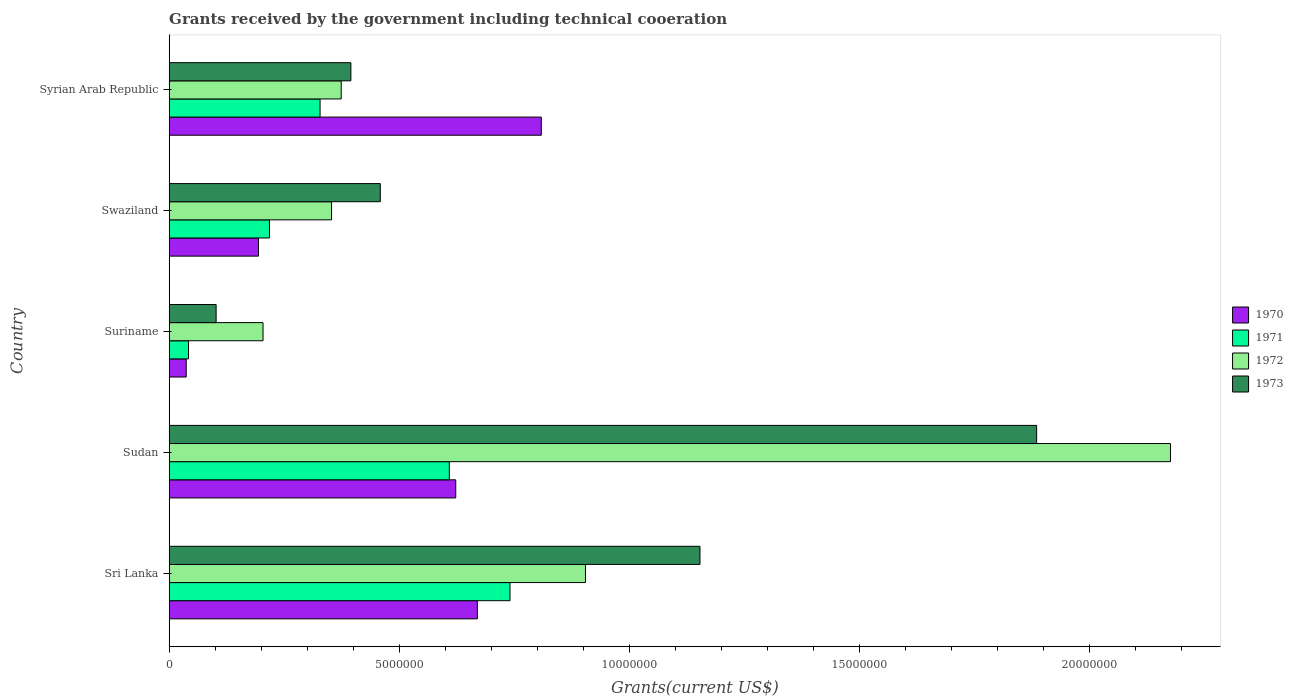Are the number of bars per tick equal to the number of legend labels?
Give a very brief answer. Yes. Are the number of bars on each tick of the Y-axis equal?
Offer a terse response. Yes. How many bars are there on the 5th tick from the bottom?
Give a very brief answer. 4. What is the label of the 3rd group of bars from the top?
Provide a short and direct response. Suriname. What is the total grants received by the government in 1973 in Sri Lanka?
Keep it short and to the point. 1.15e+07. Across all countries, what is the maximum total grants received by the government in 1973?
Your answer should be very brief. 1.89e+07. Across all countries, what is the minimum total grants received by the government in 1972?
Make the answer very short. 2.04e+06. In which country was the total grants received by the government in 1972 maximum?
Offer a very short reply. Sudan. In which country was the total grants received by the government in 1970 minimum?
Ensure brevity in your answer.  Suriname. What is the total total grants received by the government in 1971 in the graph?
Provide a short and direct response. 1.94e+07. What is the difference between the total grants received by the government in 1971 in Suriname and that in Swaziland?
Give a very brief answer. -1.76e+06. What is the difference between the total grants received by the government in 1970 in Suriname and the total grants received by the government in 1971 in Sri Lanka?
Make the answer very short. -7.04e+06. What is the average total grants received by the government in 1972 per country?
Keep it short and to the point. 8.03e+06. What is the difference between the total grants received by the government in 1971 and total grants received by the government in 1973 in Swaziland?
Give a very brief answer. -2.41e+06. In how many countries, is the total grants received by the government in 1970 greater than 17000000 US$?
Give a very brief answer. 0. What is the ratio of the total grants received by the government in 1972 in Sri Lanka to that in Suriname?
Offer a very short reply. 4.44. Is the difference between the total grants received by the government in 1971 in Sri Lanka and Sudan greater than the difference between the total grants received by the government in 1973 in Sri Lanka and Sudan?
Your answer should be very brief. Yes. What is the difference between the highest and the second highest total grants received by the government in 1970?
Keep it short and to the point. 1.39e+06. What is the difference between the highest and the lowest total grants received by the government in 1973?
Provide a succinct answer. 1.78e+07. Is the sum of the total grants received by the government in 1970 in Sudan and Suriname greater than the maximum total grants received by the government in 1973 across all countries?
Give a very brief answer. No. Is it the case that in every country, the sum of the total grants received by the government in 1972 and total grants received by the government in 1973 is greater than the sum of total grants received by the government in 1971 and total grants received by the government in 1970?
Provide a short and direct response. No. What does the 2nd bar from the top in Syrian Arab Republic represents?
Give a very brief answer. 1972. Is it the case that in every country, the sum of the total grants received by the government in 1970 and total grants received by the government in 1971 is greater than the total grants received by the government in 1973?
Your answer should be very brief. No. What is the difference between two consecutive major ticks on the X-axis?
Provide a succinct answer. 5.00e+06. Are the values on the major ticks of X-axis written in scientific E-notation?
Offer a terse response. No. How are the legend labels stacked?
Your answer should be compact. Vertical. What is the title of the graph?
Keep it short and to the point. Grants received by the government including technical cooeration. What is the label or title of the X-axis?
Your answer should be very brief. Grants(current US$). What is the Grants(current US$) in 1970 in Sri Lanka?
Make the answer very short. 6.70e+06. What is the Grants(current US$) of 1971 in Sri Lanka?
Your answer should be very brief. 7.41e+06. What is the Grants(current US$) of 1972 in Sri Lanka?
Offer a very short reply. 9.05e+06. What is the Grants(current US$) in 1973 in Sri Lanka?
Ensure brevity in your answer.  1.15e+07. What is the Grants(current US$) of 1970 in Sudan?
Provide a short and direct response. 6.23e+06. What is the Grants(current US$) in 1971 in Sudan?
Keep it short and to the point. 6.09e+06. What is the Grants(current US$) in 1972 in Sudan?
Make the answer very short. 2.18e+07. What is the Grants(current US$) in 1973 in Sudan?
Provide a short and direct response. 1.89e+07. What is the Grants(current US$) in 1972 in Suriname?
Offer a terse response. 2.04e+06. What is the Grants(current US$) in 1973 in Suriname?
Provide a short and direct response. 1.02e+06. What is the Grants(current US$) of 1970 in Swaziland?
Ensure brevity in your answer.  1.94e+06. What is the Grants(current US$) of 1971 in Swaziland?
Provide a short and direct response. 2.18e+06. What is the Grants(current US$) of 1972 in Swaziland?
Your answer should be compact. 3.53e+06. What is the Grants(current US$) in 1973 in Swaziland?
Keep it short and to the point. 4.59e+06. What is the Grants(current US$) of 1970 in Syrian Arab Republic?
Provide a succinct answer. 8.09e+06. What is the Grants(current US$) in 1971 in Syrian Arab Republic?
Keep it short and to the point. 3.28e+06. What is the Grants(current US$) in 1972 in Syrian Arab Republic?
Make the answer very short. 3.74e+06. What is the Grants(current US$) of 1973 in Syrian Arab Republic?
Give a very brief answer. 3.95e+06. Across all countries, what is the maximum Grants(current US$) of 1970?
Give a very brief answer. 8.09e+06. Across all countries, what is the maximum Grants(current US$) of 1971?
Your answer should be compact. 7.41e+06. Across all countries, what is the maximum Grants(current US$) in 1972?
Give a very brief answer. 2.18e+07. Across all countries, what is the maximum Grants(current US$) in 1973?
Provide a succinct answer. 1.89e+07. Across all countries, what is the minimum Grants(current US$) of 1970?
Give a very brief answer. 3.70e+05. Across all countries, what is the minimum Grants(current US$) of 1971?
Give a very brief answer. 4.20e+05. Across all countries, what is the minimum Grants(current US$) of 1972?
Make the answer very short. 2.04e+06. Across all countries, what is the minimum Grants(current US$) in 1973?
Ensure brevity in your answer.  1.02e+06. What is the total Grants(current US$) in 1970 in the graph?
Your answer should be compact. 2.33e+07. What is the total Grants(current US$) in 1971 in the graph?
Your response must be concise. 1.94e+07. What is the total Grants(current US$) of 1972 in the graph?
Make the answer very short. 4.01e+07. What is the total Grants(current US$) in 1973 in the graph?
Offer a very short reply. 4.00e+07. What is the difference between the Grants(current US$) of 1970 in Sri Lanka and that in Sudan?
Your response must be concise. 4.70e+05. What is the difference between the Grants(current US$) in 1971 in Sri Lanka and that in Sudan?
Provide a succinct answer. 1.32e+06. What is the difference between the Grants(current US$) of 1972 in Sri Lanka and that in Sudan?
Ensure brevity in your answer.  -1.27e+07. What is the difference between the Grants(current US$) in 1973 in Sri Lanka and that in Sudan?
Provide a succinct answer. -7.32e+06. What is the difference between the Grants(current US$) in 1970 in Sri Lanka and that in Suriname?
Make the answer very short. 6.33e+06. What is the difference between the Grants(current US$) of 1971 in Sri Lanka and that in Suriname?
Your response must be concise. 6.99e+06. What is the difference between the Grants(current US$) in 1972 in Sri Lanka and that in Suriname?
Make the answer very short. 7.01e+06. What is the difference between the Grants(current US$) of 1973 in Sri Lanka and that in Suriname?
Make the answer very short. 1.05e+07. What is the difference between the Grants(current US$) of 1970 in Sri Lanka and that in Swaziland?
Your answer should be very brief. 4.76e+06. What is the difference between the Grants(current US$) in 1971 in Sri Lanka and that in Swaziland?
Offer a terse response. 5.23e+06. What is the difference between the Grants(current US$) of 1972 in Sri Lanka and that in Swaziland?
Offer a very short reply. 5.52e+06. What is the difference between the Grants(current US$) in 1973 in Sri Lanka and that in Swaziland?
Give a very brief answer. 6.95e+06. What is the difference between the Grants(current US$) of 1970 in Sri Lanka and that in Syrian Arab Republic?
Provide a succinct answer. -1.39e+06. What is the difference between the Grants(current US$) of 1971 in Sri Lanka and that in Syrian Arab Republic?
Make the answer very short. 4.13e+06. What is the difference between the Grants(current US$) of 1972 in Sri Lanka and that in Syrian Arab Republic?
Offer a very short reply. 5.31e+06. What is the difference between the Grants(current US$) in 1973 in Sri Lanka and that in Syrian Arab Republic?
Your answer should be very brief. 7.59e+06. What is the difference between the Grants(current US$) in 1970 in Sudan and that in Suriname?
Keep it short and to the point. 5.86e+06. What is the difference between the Grants(current US$) in 1971 in Sudan and that in Suriname?
Make the answer very short. 5.67e+06. What is the difference between the Grants(current US$) of 1972 in Sudan and that in Suriname?
Your response must be concise. 1.97e+07. What is the difference between the Grants(current US$) in 1973 in Sudan and that in Suriname?
Offer a terse response. 1.78e+07. What is the difference between the Grants(current US$) in 1970 in Sudan and that in Swaziland?
Your answer should be very brief. 4.29e+06. What is the difference between the Grants(current US$) of 1971 in Sudan and that in Swaziland?
Give a very brief answer. 3.91e+06. What is the difference between the Grants(current US$) of 1972 in Sudan and that in Swaziland?
Give a very brief answer. 1.82e+07. What is the difference between the Grants(current US$) of 1973 in Sudan and that in Swaziland?
Offer a terse response. 1.43e+07. What is the difference between the Grants(current US$) of 1970 in Sudan and that in Syrian Arab Republic?
Your response must be concise. -1.86e+06. What is the difference between the Grants(current US$) of 1971 in Sudan and that in Syrian Arab Republic?
Provide a short and direct response. 2.81e+06. What is the difference between the Grants(current US$) of 1972 in Sudan and that in Syrian Arab Republic?
Your response must be concise. 1.80e+07. What is the difference between the Grants(current US$) of 1973 in Sudan and that in Syrian Arab Republic?
Offer a terse response. 1.49e+07. What is the difference between the Grants(current US$) of 1970 in Suriname and that in Swaziland?
Give a very brief answer. -1.57e+06. What is the difference between the Grants(current US$) in 1971 in Suriname and that in Swaziland?
Offer a terse response. -1.76e+06. What is the difference between the Grants(current US$) of 1972 in Suriname and that in Swaziland?
Offer a very short reply. -1.49e+06. What is the difference between the Grants(current US$) of 1973 in Suriname and that in Swaziland?
Your answer should be compact. -3.57e+06. What is the difference between the Grants(current US$) of 1970 in Suriname and that in Syrian Arab Republic?
Ensure brevity in your answer.  -7.72e+06. What is the difference between the Grants(current US$) of 1971 in Suriname and that in Syrian Arab Republic?
Keep it short and to the point. -2.86e+06. What is the difference between the Grants(current US$) in 1972 in Suriname and that in Syrian Arab Republic?
Give a very brief answer. -1.70e+06. What is the difference between the Grants(current US$) in 1973 in Suriname and that in Syrian Arab Republic?
Keep it short and to the point. -2.93e+06. What is the difference between the Grants(current US$) in 1970 in Swaziland and that in Syrian Arab Republic?
Provide a short and direct response. -6.15e+06. What is the difference between the Grants(current US$) in 1971 in Swaziland and that in Syrian Arab Republic?
Ensure brevity in your answer.  -1.10e+06. What is the difference between the Grants(current US$) in 1972 in Swaziland and that in Syrian Arab Republic?
Make the answer very short. -2.10e+05. What is the difference between the Grants(current US$) of 1973 in Swaziland and that in Syrian Arab Republic?
Provide a short and direct response. 6.40e+05. What is the difference between the Grants(current US$) of 1970 in Sri Lanka and the Grants(current US$) of 1971 in Sudan?
Your response must be concise. 6.10e+05. What is the difference between the Grants(current US$) in 1970 in Sri Lanka and the Grants(current US$) in 1972 in Sudan?
Give a very brief answer. -1.51e+07. What is the difference between the Grants(current US$) of 1970 in Sri Lanka and the Grants(current US$) of 1973 in Sudan?
Ensure brevity in your answer.  -1.22e+07. What is the difference between the Grants(current US$) in 1971 in Sri Lanka and the Grants(current US$) in 1972 in Sudan?
Provide a short and direct response. -1.44e+07. What is the difference between the Grants(current US$) of 1971 in Sri Lanka and the Grants(current US$) of 1973 in Sudan?
Keep it short and to the point. -1.14e+07. What is the difference between the Grants(current US$) in 1972 in Sri Lanka and the Grants(current US$) in 1973 in Sudan?
Your answer should be compact. -9.81e+06. What is the difference between the Grants(current US$) in 1970 in Sri Lanka and the Grants(current US$) in 1971 in Suriname?
Your response must be concise. 6.28e+06. What is the difference between the Grants(current US$) of 1970 in Sri Lanka and the Grants(current US$) of 1972 in Suriname?
Keep it short and to the point. 4.66e+06. What is the difference between the Grants(current US$) of 1970 in Sri Lanka and the Grants(current US$) of 1973 in Suriname?
Make the answer very short. 5.68e+06. What is the difference between the Grants(current US$) in 1971 in Sri Lanka and the Grants(current US$) in 1972 in Suriname?
Provide a short and direct response. 5.37e+06. What is the difference between the Grants(current US$) of 1971 in Sri Lanka and the Grants(current US$) of 1973 in Suriname?
Ensure brevity in your answer.  6.39e+06. What is the difference between the Grants(current US$) of 1972 in Sri Lanka and the Grants(current US$) of 1973 in Suriname?
Provide a succinct answer. 8.03e+06. What is the difference between the Grants(current US$) in 1970 in Sri Lanka and the Grants(current US$) in 1971 in Swaziland?
Offer a terse response. 4.52e+06. What is the difference between the Grants(current US$) in 1970 in Sri Lanka and the Grants(current US$) in 1972 in Swaziland?
Make the answer very short. 3.17e+06. What is the difference between the Grants(current US$) in 1970 in Sri Lanka and the Grants(current US$) in 1973 in Swaziland?
Your response must be concise. 2.11e+06. What is the difference between the Grants(current US$) in 1971 in Sri Lanka and the Grants(current US$) in 1972 in Swaziland?
Provide a short and direct response. 3.88e+06. What is the difference between the Grants(current US$) in 1971 in Sri Lanka and the Grants(current US$) in 1973 in Swaziland?
Ensure brevity in your answer.  2.82e+06. What is the difference between the Grants(current US$) of 1972 in Sri Lanka and the Grants(current US$) of 1973 in Swaziland?
Your answer should be very brief. 4.46e+06. What is the difference between the Grants(current US$) in 1970 in Sri Lanka and the Grants(current US$) in 1971 in Syrian Arab Republic?
Your response must be concise. 3.42e+06. What is the difference between the Grants(current US$) in 1970 in Sri Lanka and the Grants(current US$) in 1972 in Syrian Arab Republic?
Give a very brief answer. 2.96e+06. What is the difference between the Grants(current US$) in 1970 in Sri Lanka and the Grants(current US$) in 1973 in Syrian Arab Republic?
Ensure brevity in your answer.  2.75e+06. What is the difference between the Grants(current US$) in 1971 in Sri Lanka and the Grants(current US$) in 1972 in Syrian Arab Republic?
Give a very brief answer. 3.67e+06. What is the difference between the Grants(current US$) in 1971 in Sri Lanka and the Grants(current US$) in 1973 in Syrian Arab Republic?
Provide a short and direct response. 3.46e+06. What is the difference between the Grants(current US$) of 1972 in Sri Lanka and the Grants(current US$) of 1973 in Syrian Arab Republic?
Ensure brevity in your answer.  5.10e+06. What is the difference between the Grants(current US$) in 1970 in Sudan and the Grants(current US$) in 1971 in Suriname?
Your answer should be compact. 5.81e+06. What is the difference between the Grants(current US$) in 1970 in Sudan and the Grants(current US$) in 1972 in Suriname?
Provide a short and direct response. 4.19e+06. What is the difference between the Grants(current US$) in 1970 in Sudan and the Grants(current US$) in 1973 in Suriname?
Your answer should be very brief. 5.21e+06. What is the difference between the Grants(current US$) in 1971 in Sudan and the Grants(current US$) in 1972 in Suriname?
Your answer should be very brief. 4.05e+06. What is the difference between the Grants(current US$) in 1971 in Sudan and the Grants(current US$) in 1973 in Suriname?
Provide a short and direct response. 5.07e+06. What is the difference between the Grants(current US$) of 1972 in Sudan and the Grants(current US$) of 1973 in Suriname?
Offer a terse response. 2.08e+07. What is the difference between the Grants(current US$) in 1970 in Sudan and the Grants(current US$) in 1971 in Swaziland?
Ensure brevity in your answer.  4.05e+06. What is the difference between the Grants(current US$) of 1970 in Sudan and the Grants(current US$) of 1972 in Swaziland?
Make the answer very short. 2.70e+06. What is the difference between the Grants(current US$) of 1970 in Sudan and the Grants(current US$) of 1973 in Swaziland?
Provide a short and direct response. 1.64e+06. What is the difference between the Grants(current US$) of 1971 in Sudan and the Grants(current US$) of 1972 in Swaziland?
Your answer should be very brief. 2.56e+06. What is the difference between the Grants(current US$) in 1971 in Sudan and the Grants(current US$) in 1973 in Swaziland?
Ensure brevity in your answer.  1.50e+06. What is the difference between the Grants(current US$) of 1972 in Sudan and the Grants(current US$) of 1973 in Swaziland?
Offer a very short reply. 1.72e+07. What is the difference between the Grants(current US$) in 1970 in Sudan and the Grants(current US$) in 1971 in Syrian Arab Republic?
Ensure brevity in your answer.  2.95e+06. What is the difference between the Grants(current US$) of 1970 in Sudan and the Grants(current US$) of 1972 in Syrian Arab Republic?
Offer a terse response. 2.49e+06. What is the difference between the Grants(current US$) of 1970 in Sudan and the Grants(current US$) of 1973 in Syrian Arab Republic?
Provide a succinct answer. 2.28e+06. What is the difference between the Grants(current US$) of 1971 in Sudan and the Grants(current US$) of 1972 in Syrian Arab Republic?
Provide a succinct answer. 2.35e+06. What is the difference between the Grants(current US$) in 1971 in Sudan and the Grants(current US$) in 1973 in Syrian Arab Republic?
Your answer should be very brief. 2.14e+06. What is the difference between the Grants(current US$) of 1972 in Sudan and the Grants(current US$) of 1973 in Syrian Arab Republic?
Ensure brevity in your answer.  1.78e+07. What is the difference between the Grants(current US$) in 1970 in Suriname and the Grants(current US$) in 1971 in Swaziland?
Provide a succinct answer. -1.81e+06. What is the difference between the Grants(current US$) of 1970 in Suriname and the Grants(current US$) of 1972 in Swaziland?
Provide a succinct answer. -3.16e+06. What is the difference between the Grants(current US$) in 1970 in Suriname and the Grants(current US$) in 1973 in Swaziland?
Your answer should be compact. -4.22e+06. What is the difference between the Grants(current US$) of 1971 in Suriname and the Grants(current US$) of 1972 in Swaziland?
Ensure brevity in your answer.  -3.11e+06. What is the difference between the Grants(current US$) of 1971 in Suriname and the Grants(current US$) of 1973 in Swaziland?
Make the answer very short. -4.17e+06. What is the difference between the Grants(current US$) of 1972 in Suriname and the Grants(current US$) of 1973 in Swaziland?
Provide a succinct answer. -2.55e+06. What is the difference between the Grants(current US$) of 1970 in Suriname and the Grants(current US$) of 1971 in Syrian Arab Republic?
Your response must be concise. -2.91e+06. What is the difference between the Grants(current US$) of 1970 in Suriname and the Grants(current US$) of 1972 in Syrian Arab Republic?
Make the answer very short. -3.37e+06. What is the difference between the Grants(current US$) of 1970 in Suriname and the Grants(current US$) of 1973 in Syrian Arab Republic?
Offer a terse response. -3.58e+06. What is the difference between the Grants(current US$) in 1971 in Suriname and the Grants(current US$) in 1972 in Syrian Arab Republic?
Provide a short and direct response. -3.32e+06. What is the difference between the Grants(current US$) of 1971 in Suriname and the Grants(current US$) of 1973 in Syrian Arab Republic?
Your answer should be compact. -3.53e+06. What is the difference between the Grants(current US$) in 1972 in Suriname and the Grants(current US$) in 1973 in Syrian Arab Republic?
Your answer should be compact. -1.91e+06. What is the difference between the Grants(current US$) of 1970 in Swaziland and the Grants(current US$) of 1971 in Syrian Arab Republic?
Give a very brief answer. -1.34e+06. What is the difference between the Grants(current US$) in 1970 in Swaziland and the Grants(current US$) in 1972 in Syrian Arab Republic?
Keep it short and to the point. -1.80e+06. What is the difference between the Grants(current US$) of 1970 in Swaziland and the Grants(current US$) of 1973 in Syrian Arab Republic?
Your answer should be very brief. -2.01e+06. What is the difference between the Grants(current US$) in 1971 in Swaziland and the Grants(current US$) in 1972 in Syrian Arab Republic?
Your answer should be very brief. -1.56e+06. What is the difference between the Grants(current US$) in 1971 in Swaziland and the Grants(current US$) in 1973 in Syrian Arab Republic?
Your answer should be compact. -1.77e+06. What is the difference between the Grants(current US$) in 1972 in Swaziland and the Grants(current US$) in 1973 in Syrian Arab Republic?
Your answer should be very brief. -4.20e+05. What is the average Grants(current US$) of 1970 per country?
Offer a very short reply. 4.67e+06. What is the average Grants(current US$) in 1971 per country?
Make the answer very short. 3.88e+06. What is the average Grants(current US$) of 1972 per country?
Your answer should be compact. 8.03e+06. What is the average Grants(current US$) of 1973 per country?
Keep it short and to the point. 7.99e+06. What is the difference between the Grants(current US$) in 1970 and Grants(current US$) in 1971 in Sri Lanka?
Your answer should be compact. -7.10e+05. What is the difference between the Grants(current US$) of 1970 and Grants(current US$) of 1972 in Sri Lanka?
Offer a very short reply. -2.35e+06. What is the difference between the Grants(current US$) of 1970 and Grants(current US$) of 1973 in Sri Lanka?
Your answer should be compact. -4.84e+06. What is the difference between the Grants(current US$) in 1971 and Grants(current US$) in 1972 in Sri Lanka?
Make the answer very short. -1.64e+06. What is the difference between the Grants(current US$) in 1971 and Grants(current US$) in 1973 in Sri Lanka?
Offer a very short reply. -4.13e+06. What is the difference between the Grants(current US$) of 1972 and Grants(current US$) of 1973 in Sri Lanka?
Your response must be concise. -2.49e+06. What is the difference between the Grants(current US$) of 1970 and Grants(current US$) of 1972 in Sudan?
Give a very brief answer. -1.55e+07. What is the difference between the Grants(current US$) in 1970 and Grants(current US$) in 1973 in Sudan?
Your answer should be compact. -1.26e+07. What is the difference between the Grants(current US$) in 1971 and Grants(current US$) in 1972 in Sudan?
Your answer should be compact. -1.57e+07. What is the difference between the Grants(current US$) in 1971 and Grants(current US$) in 1973 in Sudan?
Your response must be concise. -1.28e+07. What is the difference between the Grants(current US$) of 1972 and Grants(current US$) of 1973 in Sudan?
Provide a succinct answer. 2.91e+06. What is the difference between the Grants(current US$) of 1970 and Grants(current US$) of 1972 in Suriname?
Provide a succinct answer. -1.67e+06. What is the difference between the Grants(current US$) in 1970 and Grants(current US$) in 1973 in Suriname?
Make the answer very short. -6.50e+05. What is the difference between the Grants(current US$) in 1971 and Grants(current US$) in 1972 in Suriname?
Give a very brief answer. -1.62e+06. What is the difference between the Grants(current US$) of 1971 and Grants(current US$) of 1973 in Suriname?
Keep it short and to the point. -6.00e+05. What is the difference between the Grants(current US$) in 1972 and Grants(current US$) in 1973 in Suriname?
Provide a succinct answer. 1.02e+06. What is the difference between the Grants(current US$) in 1970 and Grants(current US$) in 1971 in Swaziland?
Your response must be concise. -2.40e+05. What is the difference between the Grants(current US$) of 1970 and Grants(current US$) of 1972 in Swaziland?
Give a very brief answer. -1.59e+06. What is the difference between the Grants(current US$) of 1970 and Grants(current US$) of 1973 in Swaziland?
Your response must be concise. -2.65e+06. What is the difference between the Grants(current US$) in 1971 and Grants(current US$) in 1972 in Swaziland?
Your response must be concise. -1.35e+06. What is the difference between the Grants(current US$) of 1971 and Grants(current US$) of 1973 in Swaziland?
Offer a very short reply. -2.41e+06. What is the difference between the Grants(current US$) in 1972 and Grants(current US$) in 1973 in Swaziland?
Provide a succinct answer. -1.06e+06. What is the difference between the Grants(current US$) of 1970 and Grants(current US$) of 1971 in Syrian Arab Republic?
Provide a succinct answer. 4.81e+06. What is the difference between the Grants(current US$) of 1970 and Grants(current US$) of 1972 in Syrian Arab Republic?
Your answer should be very brief. 4.35e+06. What is the difference between the Grants(current US$) in 1970 and Grants(current US$) in 1973 in Syrian Arab Republic?
Ensure brevity in your answer.  4.14e+06. What is the difference between the Grants(current US$) of 1971 and Grants(current US$) of 1972 in Syrian Arab Republic?
Offer a terse response. -4.60e+05. What is the difference between the Grants(current US$) of 1971 and Grants(current US$) of 1973 in Syrian Arab Republic?
Provide a short and direct response. -6.70e+05. What is the ratio of the Grants(current US$) of 1970 in Sri Lanka to that in Sudan?
Offer a very short reply. 1.08. What is the ratio of the Grants(current US$) in 1971 in Sri Lanka to that in Sudan?
Your answer should be very brief. 1.22. What is the ratio of the Grants(current US$) in 1972 in Sri Lanka to that in Sudan?
Provide a succinct answer. 0.42. What is the ratio of the Grants(current US$) in 1973 in Sri Lanka to that in Sudan?
Offer a very short reply. 0.61. What is the ratio of the Grants(current US$) in 1970 in Sri Lanka to that in Suriname?
Ensure brevity in your answer.  18.11. What is the ratio of the Grants(current US$) in 1971 in Sri Lanka to that in Suriname?
Give a very brief answer. 17.64. What is the ratio of the Grants(current US$) of 1972 in Sri Lanka to that in Suriname?
Give a very brief answer. 4.44. What is the ratio of the Grants(current US$) in 1973 in Sri Lanka to that in Suriname?
Offer a terse response. 11.31. What is the ratio of the Grants(current US$) of 1970 in Sri Lanka to that in Swaziland?
Provide a short and direct response. 3.45. What is the ratio of the Grants(current US$) of 1971 in Sri Lanka to that in Swaziland?
Offer a very short reply. 3.4. What is the ratio of the Grants(current US$) of 1972 in Sri Lanka to that in Swaziland?
Your answer should be very brief. 2.56. What is the ratio of the Grants(current US$) of 1973 in Sri Lanka to that in Swaziland?
Your answer should be very brief. 2.51. What is the ratio of the Grants(current US$) in 1970 in Sri Lanka to that in Syrian Arab Republic?
Give a very brief answer. 0.83. What is the ratio of the Grants(current US$) of 1971 in Sri Lanka to that in Syrian Arab Republic?
Your answer should be compact. 2.26. What is the ratio of the Grants(current US$) in 1972 in Sri Lanka to that in Syrian Arab Republic?
Give a very brief answer. 2.42. What is the ratio of the Grants(current US$) in 1973 in Sri Lanka to that in Syrian Arab Republic?
Offer a very short reply. 2.92. What is the ratio of the Grants(current US$) of 1970 in Sudan to that in Suriname?
Offer a very short reply. 16.84. What is the ratio of the Grants(current US$) of 1971 in Sudan to that in Suriname?
Offer a very short reply. 14.5. What is the ratio of the Grants(current US$) in 1972 in Sudan to that in Suriname?
Provide a succinct answer. 10.67. What is the ratio of the Grants(current US$) of 1973 in Sudan to that in Suriname?
Your answer should be very brief. 18.49. What is the ratio of the Grants(current US$) in 1970 in Sudan to that in Swaziland?
Provide a succinct answer. 3.21. What is the ratio of the Grants(current US$) of 1971 in Sudan to that in Swaziland?
Offer a terse response. 2.79. What is the ratio of the Grants(current US$) of 1972 in Sudan to that in Swaziland?
Provide a succinct answer. 6.17. What is the ratio of the Grants(current US$) of 1973 in Sudan to that in Swaziland?
Make the answer very short. 4.11. What is the ratio of the Grants(current US$) of 1970 in Sudan to that in Syrian Arab Republic?
Offer a very short reply. 0.77. What is the ratio of the Grants(current US$) in 1971 in Sudan to that in Syrian Arab Republic?
Provide a succinct answer. 1.86. What is the ratio of the Grants(current US$) in 1972 in Sudan to that in Syrian Arab Republic?
Your answer should be very brief. 5.82. What is the ratio of the Grants(current US$) in 1973 in Sudan to that in Syrian Arab Republic?
Offer a very short reply. 4.77. What is the ratio of the Grants(current US$) in 1970 in Suriname to that in Swaziland?
Offer a very short reply. 0.19. What is the ratio of the Grants(current US$) in 1971 in Suriname to that in Swaziland?
Provide a succinct answer. 0.19. What is the ratio of the Grants(current US$) of 1972 in Suriname to that in Swaziland?
Ensure brevity in your answer.  0.58. What is the ratio of the Grants(current US$) of 1973 in Suriname to that in Swaziland?
Your answer should be very brief. 0.22. What is the ratio of the Grants(current US$) in 1970 in Suriname to that in Syrian Arab Republic?
Your answer should be very brief. 0.05. What is the ratio of the Grants(current US$) in 1971 in Suriname to that in Syrian Arab Republic?
Provide a short and direct response. 0.13. What is the ratio of the Grants(current US$) in 1972 in Suriname to that in Syrian Arab Republic?
Make the answer very short. 0.55. What is the ratio of the Grants(current US$) in 1973 in Suriname to that in Syrian Arab Republic?
Your response must be concise. 0.26. What is the ratio of the Grants(current US$) in 1970 in Swaziland to that in Syrian Arab Republic?
Keep it short and to the point. 0.24. What is the ratio of the Grants(current US$) of 1971 in Swaziland to that in Syrian Arab Republic?
Offer a terse response. 0.66. What is the ratio of the Grants(current US$) of 1972 in Swaziland to that in Syrian Arab Republic?
Give a very brief answer. 0.94. What is the ratio of the Grants(current US$) of 1973 in Swaziland to that in Syrian Arab Republic?
Offer a terse response. 1.16. What is the difference between the highest and the second highest Grants(current US$) in 1970?
Give a very brief answer. 1.39e+06. What is the difference between the highest and the second highest Grants(current US$) of 1971?
Provide a succinct answer. 1.32e+06. What is the difference between the highest and the second highest Grants(current US$) of 1972?
Give a very brief answer. 1.27e+07. What is the difference between the highest and the second highest Grants(current US$) of 1973?
Offer a very short reply. 7.32e+06. What is the difference between the highest and the lowest Grants(current US$) of 1970?
Your answer should be very brief. 7.72e+06. What is the difference between the highest and the lowest Grants(current US$) in 1971?
Your response must be concise. 6.99e+06. What is the difference between the highest and the lowest Grants(current US$) in 1972?
Provide a short and direct response. 1.97e+07. What is the difference between the highest and the lowest Grants(current US$) in 1973?
Give a very brief answer. 1.78e+07. 